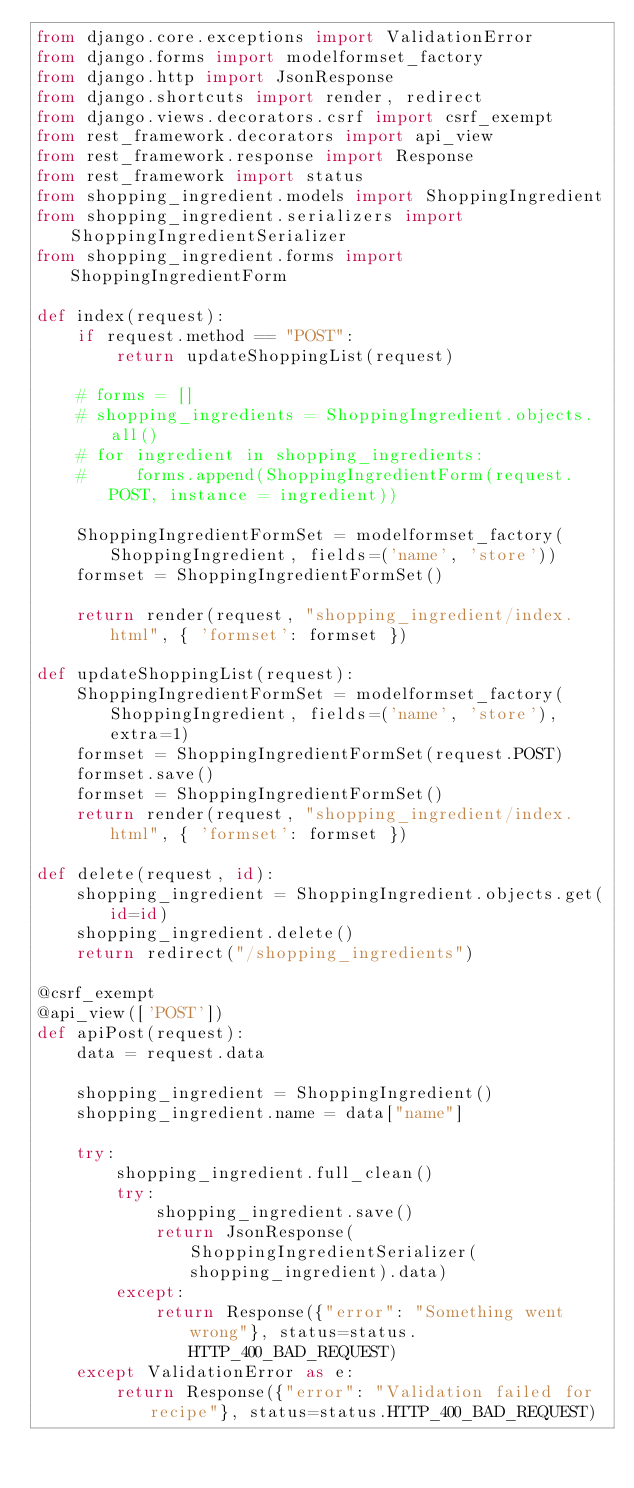<code> <loc_0><loc_0><loc_500><loc_500><_Python_>from django.core.exceptions import ValidationError
from django.forms import modelformset_factory
from django.http import JsonResponse
from django.shortcuts import render, redirect 
from django.views.decorators.csrf import csrf_exempt
from rest_framework.decorators import api_view
from rest_framework.response import Response
from rest_framework import status
from shopping_ingredient.models import ShoppingIngredient
from shopping_ingredient.serializers import ShoppingIngredientSerializer
from shopping_ingredient.forms import ShoppingIngredientForm

def index(request):  
    if request.method == "POST":  
        return updateShoppingList(request)
        
    # forms = []
    # shopping_ingredients = ShoppingIngredient.objects.all()  
    # for ingredient in shopping_ingredients:
    #     forms.append(ShoppingIngredientForm(request.POST, instance = ingredient))

    ShoppingIngredientFormSet = modelformset_factory(ShoppingIngredient, fields=('name', 'store'))
    formset = ShoppingIngredientFormSet()

    return render(request, "shopping_ingredient/index.html", { 'formset': formset })  

def updateShoppingList(request):
    ShoppingIngredientFormSet = modelformset_factory(ShoppingIngredient, fields=('name', 'store'), extra=1)
    formset = ShoppingIngredientFormSet(request.POST)
    formset.save()  
    formset = ShoppingIngredientFormSet()
    return render(request, "shopping_ingredient/index.html", { 'formset': formset })  

def delete(request, id):
    shopping_ingredient = ShoppingIngredient.objects.get(id=id)  
    shopping_ingredient.delete()  
    return redirect("/shopping_ingredients") 

@csrf_exempt
@api_view(['POST'])
def apiPost(request):
    data = request.data

    shopping_ingredient = ShoppingIngredient()
    shopping_ingredient.name = data["name"]

    try:
        shopping_ingredient.full_clean() 
        try:  
            shopping_ingredient.save()  
            return JsonResponse(ShoppingIngredientSerializer(shopping_ingredient).data) 
        except: 
            return Response({"error": "Something went wrong"}, status=status.HTTP_400_BAD_REQUEST)  
    except ValidationError as e:
        return Response({"error": "Validation failed for recipe"}, status=status.HTTP_400_BAD_REQUEST) 
  

</code> 